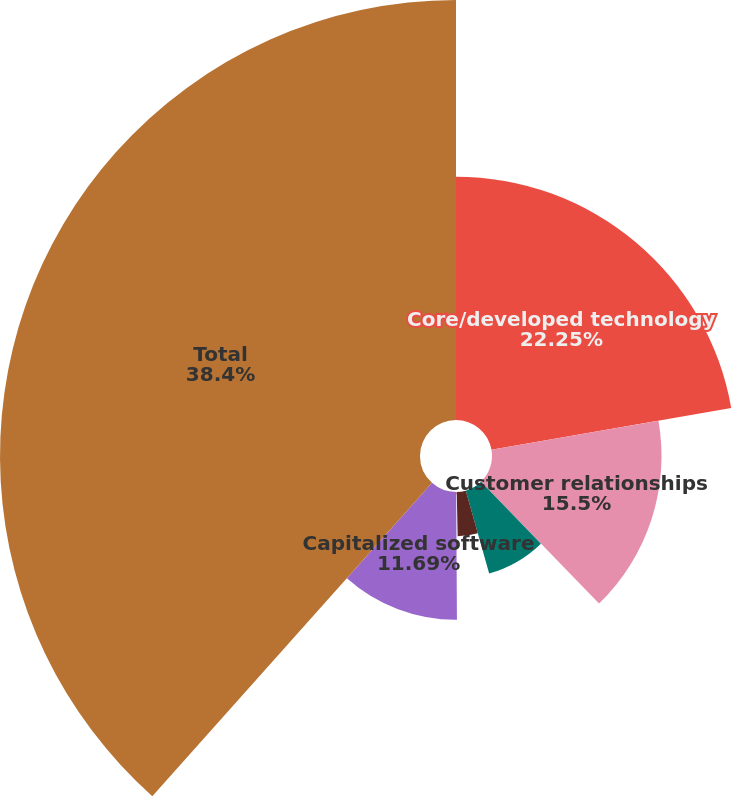Convert chart. <chart><loc_0><loc_0><loc_500><loc_500><pie_chart><fcel>Core/developed technology<fcel>Customer relationships<fcel>Contract rights intangible<fcel>Covenants not to compete<fcel>Trademarks and trade names<fcel>Capitalized software<fcel>Total<nl><fcel>22.25%<fcel>15.5%<fcel>7.87%<fcel>4.05%<fcel>0.24%<fcel>11.69%<fcel>38.4%<nl></chart> 